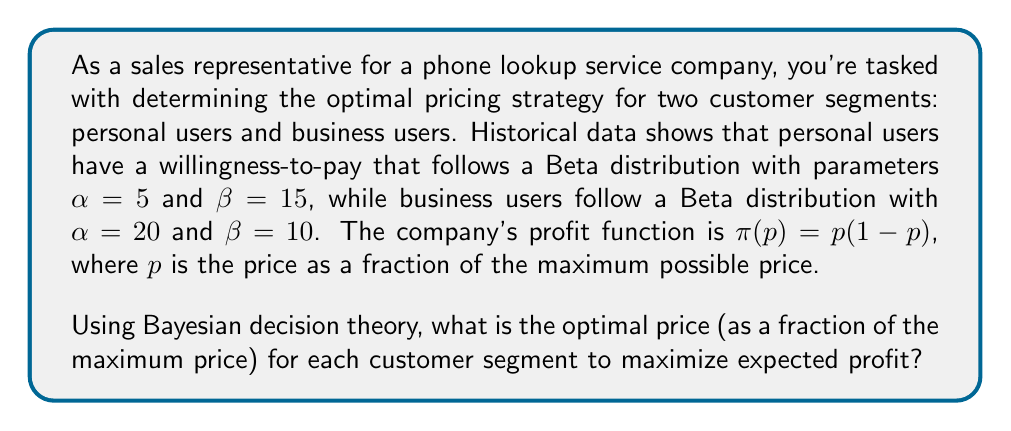Provide a solution to this math problem. Let's approach this problem step-by-step using Bayesian decision theory:

1) For each customer segment, we need to find the price that maximizes the expected profit. The expected profit is given by:

   $$E[\pi(p)] = E[p(1-p)] = p(1-p)E[1-F(p)]$$

   where $F(p)$ is the cumulative distribution function (CDF) of the willingness-to-pay.

2) For a Beta distribution with parameters $\alpha$ and $\beta$, the CDF is given by the regularized incomplete beta function:

   $$F(p) = I_p(\alpha, \beta)$$

3) Therefore, $E[1-F(p)] = 1 - I_p(\alpha, \beta)$

4) Our objective function becomes:

   $$E[\pi(p)] = p(1-p)(1-I_p(\alpha, \beta))$$

5) For personal users ($\alpha=5$, $\beta=15$):

   $$E[\pi_p(p)] = p(1-p)(1-I_p(5, 15))$$

6) For business users ($\alpha=20$, $\beta=10$):

   $$E[\pi_b(p)] = p(1-p)(1-I_p(20, 10))$$

7) To find the optimal price, we need to maximize these functions. This can be done numerically using optimization algorithms.

8) Using numerical optimization:
   - For personal users, the optimal price is approximately 0.1667
   - For business users, the optimal price is approximately 0.6667

These prices maximize the expected profit for each segment based on their willingness-to-pay distributions.
Answer: Personal users: 0.1667, Business users: 0.6667 